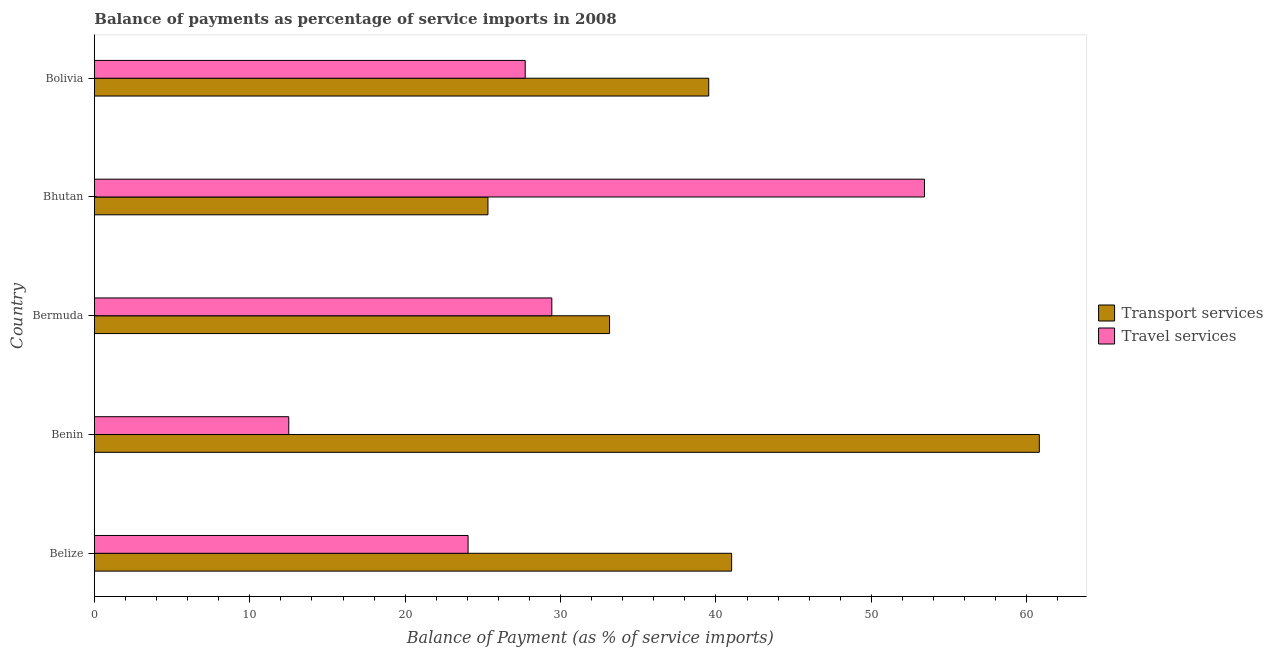How many groups of bars are there?
Give a very brief answer. 5. Are the number of bars per tick equal to the number of legend labels?
Give a very brief answer. Yes. Are the number of bars on each tick of the Y-axis equal?
Your response must be concise. Yes. How many bars are there on the 3rd tick from the top?
Offer a terse response. 2. How many bars are there on the 2nd tick from the bottom?
Provide a succinct answer. 2. What is the label of the 5th group of bars from the top?
Offer a very short reply. Belize. In how many cases, is the number of bars for a given country not equal to the number of legend labels?
Your answer should be very brief. 0. What is the balance of payments of travel services in Belize?
Ensure brevity in your answer.  24.05. Across all countries, what is the maximum balance of payments of travel services?
Provide a short and direct response. 53.42. Across all countries, what is the minimum balance of payments of travel services?
Offer a terse response. 12.51. In which country was the balance of payments of transport services maximum?
Provide a succinct answer. Benin. In which country was the balance of payments of travel services minimum?
Make the answer very short. Benin. What is the total balance of payments of transport services in the graph?
Provide a succinct answer. 199.83. What is the difference between the balance of payments of transport services in Belize and that in Benin?
Your response must be concise. -19.8. What is the difference between the balance of payments of transport services in Bermuda and the balance of payments of travel services in Belize?
Offer a terse response. 9.1. What is the average balance of payments of transport services per country?
Ensure brevity in your answer.  39.97. What is the difference between the balance of payments of transport services and balance of payments of travel services in Bolivia?
Your answer should be compact. 11.81. What is the ratio of the balance of payments of travel services in Belize to that in Bhutan?
Make the answer very short. 0.45. What is the difference between the highest and the second highest balance of payments of travel services?
Provide a succinct answer. 23.98. What is the difference between the highest and the lowest balance of payments of travel services?
Offer a very short reply. 40.9. In how many countries, is the balance of payments of travel services greater than the average balance of payments of travel services taken over all countries?
Provide a succinct answer. 2. Is the sum of the balance of payments of transport services in Benin and Bolivia greater than the maximum balance of payments of travel services across all countries?
Provide a short and direct response. Yes. What does the 2nd bar from the top in Bermuda represents?
Offer a very short reply. Transport services. What does the 1st bar from the bottom in Bermuda represents?
Provide a succinct answer. Transport services. How many bars are there?
Offer a very short reply. 10. Are all the bars in the graph horizontal?
Your answer should be very brief. Yes. How many countries are there in the graph?
Offer a terse response. 5. Are the values on the major ticks of X-axis written in scientific E-notation?
Your response must be concise. No. Does the graph contain grids?
Give a very brief answer. No. What is the title of the graph?
Ensure brevity in your answer.  Balance of payments as percentage of service imports in 2008. What is the label or title of the X-axis?
Make the answer very short. Balance of Payment (as % of service imports). What is the Balance of Payment (as % of service imports) of Transport services in Belize?
Offer a very short reply. 41.01. What is the Balance of Payment (as % of service imports) in Travel services in Belize?
Your response must be concise. 24.05. What is the Balance of Payment (as % of service imports) in Transport services in Benin?
Keep it short and to the point. 60.81. What is the Balance of Payment (as % of service imports) of Travel services in Benin?
Your answer should be very brief. 12.51. What is the Balance of Payment (as % of service imports) of Transport services in Bermuda?
Offer a terse response. 33.15. What is the Balance of Payment (as % of service imports) in Travel services in Bermuda?
Provide a succinct answer. 29.44. What is the Balance of Payment (as % of service imports) of Transport services in Bhutan?
Provide a short and direct response. 25.33. What is the Balance of Payment (as % of service imports) in Travel services in Bhutan?
Offer a terse response. 53.42. What is the Balance of Payment (as % of service imports) of Transport services in Bolivia?
Offer a terse response. 39.53. What is the Balance of Payment (as % of service imports) in Travel services in Bolivia?
Provide a short and direct response. 27.73. Across all countries, what is the maximum Balance of Payment (as % of service imports) in Transport services?
Your response must be concise. 60.81. Across all countries, what is the maximum Balance of Payment (as % of service imports) of Travel services?
Offer a terse response. 53.42. Across all countries, what is the minimum Balance of Payment (as % of service imports) in Transport services?
Ensure brevity in your answer.  25.33. Across all countries, what is the minimum Balance of Payment (as % of service imports) in Travel services?
Provide a short and direct response. 12.51. What is the total Balance of Payment (as % of service imports) in Transport services in the graph?
Offer a very short reply. 199.83. What is the total Balance of Payment (as % of service imports) in Travel services in the graph?
Provide a succinct answer. 147.14. What is the difference between the Balance of Payment (as % of service imports) of Transport services in Belize and that in Benin?
Your answer should be very brief. -19.8. What is the difference between the Balance of Payment (as % of service imports) in Travel services in Belize and that in Benin?
Provide a short and direct response. 11.54. What is the difference between the Balance of Payment (as % of service imports) in Transport services in Belize and that in Bermuda?
Ensure brevity in your answer.  7.85. What is the difference between the Balance of Payment (as % of service imports) of Travel services in Belize and that in Bermuda?
Provide a short and direct response. -5.39. What is the difference between the Balance of Payment (as % of service imports) in Transport services in Belize and that in Bhutan?
Your response must be concise. 15.68. What is the difference between the Balance of Payment (as % of service imports) in Travel services in Belize and that in Bhutan?
Give a very brief answer. -29.37. What is the difference between the Balance of Payment (as % of service imports) in Transport services in Belize and that in Bolivia?
Your answer should be very brief. 1.47. What is the difference between the Balance of Payment (as % of service imports) in Travel services in Belize and that in Bolivia?
Provide a succinct answer. -3.68. What is the difference between the Balance of Payment (as % of service imports) of Transport services in Benin and that in Bermuda?
Your answer should be compact. 27.65. What is the difference between the Balance of Payment (as % of service imports) of Travel services in Benin and that in Bermuda?
Offer a terse response. -16.93. What is the difference between the Balance of Payment (as % of service imports) of Transport services in Benin and that in Bhutan?
Give a very brief answer. 35.48. What is the difference between the Balance of Payment (as % of service imports) in Travel services in Benin and that in Bhutan?
Provide a succinct answer. -40.9. What is the difference between the Balance of Payment (as % of service imports) of Transport services in Benin and that in Bolivia?
Offer a very short reply. 21.27. What is the difference between the Balance of Payment (as % of service imports) in Travel services in Benin and that in Bolivia?
Offer a terse response. -15.21. What is the difference between the Balance of Payment (as % of service imports) of Transport services in Bermuda and that in Bhutan?
Offer a very short reply. 7.83. What is the difference between the Balance of Payment (as % of service imports) of Travel services in Bermuda and that in Bhutan?
Offer a very short reply. -23.98. What is the difference between the Balance of Payment (as % of service imports) in Transport services in Bermuda and that in Bolivia?
Ensure brevity in your answer.  -6.38. What is the difference between the Balance of Payment (as % of service imports) in Travel services in Bermuda and that in Bolivia?
Your response must be concise. 1.71. What is the difference between the Balance of Payment (as % of service imports) of Transport services in Bhutan and that in Bolivia?
Keep it short and to the point. -14.21. What is the difference between the Balance of Payment (as % of service imports) of Travel services in Bhutan and that in Bolivia?
Make the answer very short. 25.69. What is the difference between the Balance of Payment (as % of service imports) in Transport services in Belize and the Balance of Payment (as % of service imports) in Travel services in Benin?
Offer a very short reply. 28.5. What is the difference between the Balance of Payment (as % of service imports) in Transport services in Belize and the Balance of Payment (as % of service imports) in Travel services in Bermuda?
Your response must be concise. 11.57. What is the difference between the Balance of Payment (as % of service imports) of Transport services in Belize and the Balance of Payment (as % of service imports) of Travel services in Bhutan?
Your answer should be compact. -12.41. What is the difference between the Balance of Payment (as % of service imports) of Transport services in Belize and the Balance of Payment (as % of service imports) of Travel services in Bolivia?
Give a very brief answer. 13.28. What is the difference between the Balance of Payment (as % of service imports) of Transport services in Benin and the Balance of Payment (as % of service imports) of Travel services in Bermuda?
Provide a short and direct response. 31.37. What is the difference between the Balance of Payment (as % of service imports) in Transport services in Benin and the Balance of Payment (as % of service imports) in Travel services in Bhutan?
Your response must be concise. 7.39. What is the difference between the Balance of Payment (as % of service imports) of Transport services in Benin and the Balance of Payment (as % of service imports) of Travel services in Bolivia?
Provide a succinct answer. 33.08. What is the difference between the Balance of Payment (as % of service imports) in Transport services in Bermuda and the Balance of Payment (as % of service imports) in Travel services in Bhutan?
Your answer should be compact. -20.26. What is the difference between the Balance of Payment (as % of service imports) of Transport services in Bermuda and the Balance of Payment (as % of service imports) of Travel services in Bolivia?
Your response must be concise. 5.43. What is the difference between the Balance of Payment (as % of service imports) in Transport services in Bhutan and the Balance of Payment (as % of service imports) in Travel services in Bolivia?
Keep it short and to the point. -2.4. What is the average Balance of Payment (as % of service imports) in Transport services per country?
Offer a very short reply. 39.97. What is the average Balance of Payment (as % of service imports) of Travel services per country?
Your response must be concise. 29.43. What is the difference between the Balance of Payment (as % of service imports) of Transport services and Balance of Payment (as % of service imports) of Travel services in Belize?
Provide a short and direct response. 16.96. What is the difference between the Balance of Payment (as % of service imports) of Transport services and Balance of Payment (as % of service imports) of Travel services in Benin?
Give a very brief answer. 48.29. What is the difference between the Balance of Payment (as % of service imports) of Transport services and Balance of Payment (as % of service imports) of Travel services in Bermuda?
Offer a terse response. 3.72. What is the difference between the Balance of Payment (as % of service imports) of Transport services and Balance of Payment (as % of service imports) of Travel services in Bhutan?
Make the answer very short. -28.09. What is the difference between the Balance of Payment (as % of service imports) in Transport services and Balance of Payment (as % of service imports) in Travel services in Bolivia?
Your answer should be very brief. 11.81. What is the ratio of the Balance of Payment (as % of service imports) of Transport services in Belize to that in Benin?
Your response must be concise. 0.67. What is the ratio of the Balance of Payment (as % of service imports) of Travel services in Belize to that in Benin?
Your answer should be compact. 1.92. What is the ratio of the Balance of Payment (as % of service imports) of Transport services in Belize to that in Bermuda?
Keep it short and to the point. 1.24. What is the ratio of the Balance of Payment (as % of service imports) of Travel services in Belize to that in Bermuda?
Your answer should be very brief. 0.82. What is the ratio of the Balance of Payment (as % of service imports) of Transport services in Belize to that in Bhutan?
Your answer should be very brief. 1.62. What is the ratio of the Balance of Payment (as % of service imports) in Travel services in Belize to that in Bhutan?
Your answer should be compact. 0.45. What is the ratio of the Balance of Payment (as % of service imports) in Transport services in Belize to that in Bolivia?
Offer a very short reply. 1.04. What is the ratio of the Balance of Payment (as % of service imports) in Travel services in Belize to that in Bolivia?
Your answer should be very brief. 0.87. What is the ratio of the Balance of Payment (as % of service imports) of Transport services in Benin to that in Bermuda?
Offer a very short reply. 1.83. What is the ratio of the Balance of Payment (as % of service imports) in Travel services in Benin to that in Bermuda?
Your answer should be very brief. 0.42. What is the ratio of the Balance of Payment (as % of service imports) in Transport services in Benin to that in Bhutan?
Provide a short and direct response. 2.4. What is the ratio of the Balance of Payment (as % of service imports) in Travel services in Benin to that in Bhutan?
Give a very brief answer. 0.23. What is the ratio of the Balance of Payment (as % of service imports) in Transport services in Benin to that in Bolivia?
Your answer should be compact. 1.54. What is the ratio of the Balance of Payment (as % of service imports) in Travel services in Benin to that in Bolivia?
Your answer should be very brief. 0.45. What is the ratio of the Balance of Payment (as % of service imports) in Transport services in Bermuda to that in Bhutan?
Provide a succinct answer. 1.31. What is the ratio of the Balance of Payment (as % of service imports) of Travel services in Bermuda to that in Bhutan?
Make the answer very short. 0.55. What is the ratio of the Balance of Payment (as % of service imports) of Transport services in Bermuda to that in Bolivia?
Provide a succinct answer. 0.84. What is the ratio of the Balance of Payment (as % of service imports) of Travel services in Bermuda to that in Bolivia?
Make the answer very short. 1.06. What is the ratio of the Balance of Payment (as % of service imports) of Transport services in Bhutan to that in Bolivia?
Make the answer very short. 0.64. What is the ratio of the Balance of Payment (as % of service imports) of Travel services in Bhutan to that in Bolivia?
Make the answer very short. 1.93. What is the difference between the highest and the second highest Balance of Payment (as % of service imports) in Transport services?
Your response must be concise. 19.8. What is the difference between the highest and the second highest Balance of Payment (as % of service imports) in Travel services?
Your answer should be very brief. 23.98. What is the difference between the highest and the lowest Balance of Payment (as % of service imports) of Transport services?
Your response must be concise. 35.48. What is the difference between the highest and the lowest Balance of Payment (as % of service imports) of Travel services?
Ensure brevity in your answer.  40.9. 